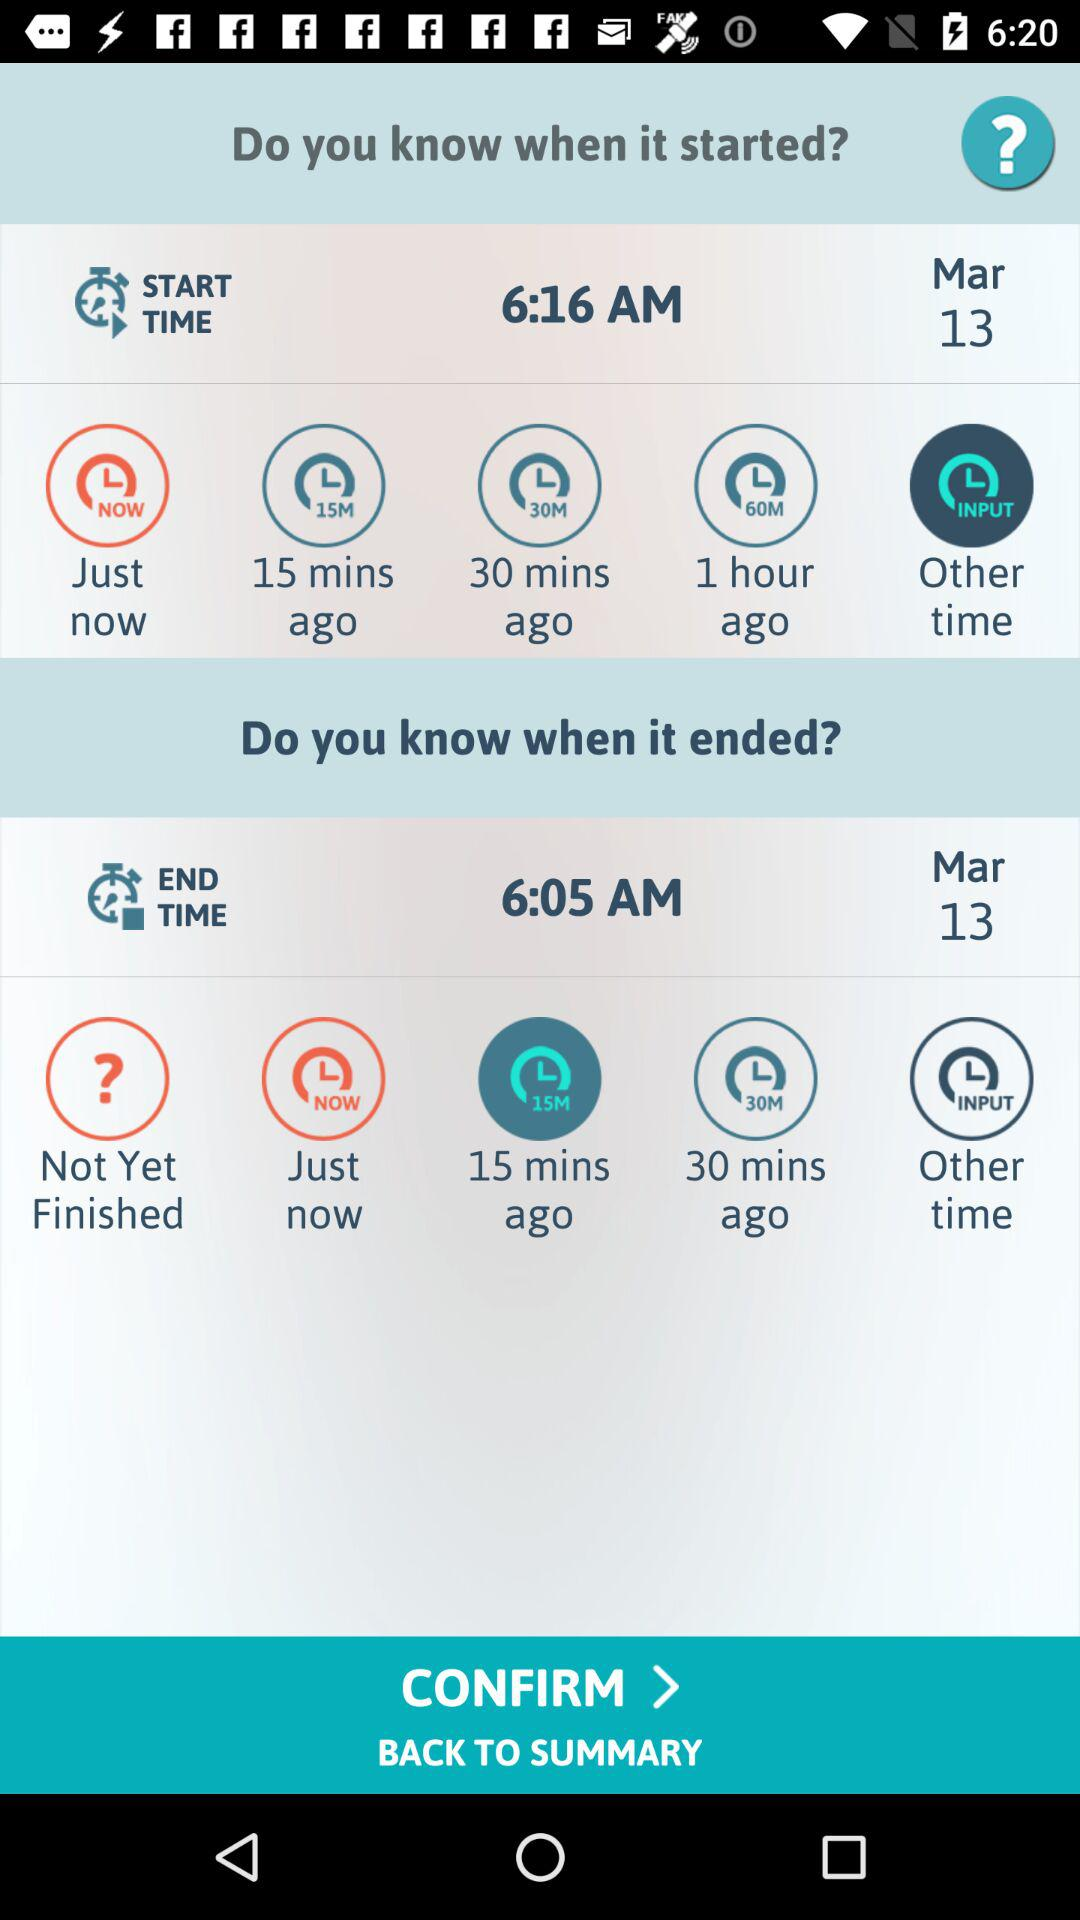What is the date? The date is March 13. 